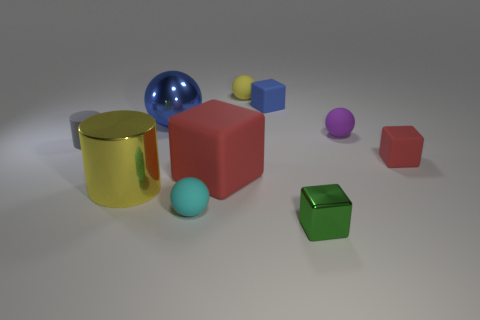How many other objects are there of the same material as the large red block?
Your answer should be compact. 6. How big is the green metal cube?
Ensure brevity in your answer.  Small. Is there another red matte object that has the same shape as the tiny red rubber object?
Offer a terse response. Yes. What number of objects are either tiny purple matte objects or small rubber spheres to the left of the small green cube?
Make the answer very short. 3. What color is the tiny rubber cube that is to the left of the shiny cube?
Offer a very short reply. Blue. Is the size of the sphere that is in front of the large cylinder the same as the red cube that is on the right side of the tiny purple rubber ball?
Keep it short and to the point. Yes. Are there any cyan rubber objects that have the same size as the green metal block?
Provide a succinct answer. Yes. How many things are to the left of the blue thing that is to the left of the small blue object?
Your response must be concise. 2. What material is the tiny red cube?
Your answer should be compact. Rubber. There is a yellow metal object; how many purple spheres are in front of it?
Your response must be concise. 0. 